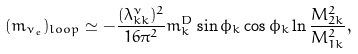Convert formula to latex. <formula><loc_0><loc_0><loc_500><loc_500>( m _ { \nu _ { e } } ) _ { l o o p } \simeq - \frac { ( \lambda ^ { \nu } _ { k k } ) ^ { 2 } } { 1 6 \pi ^ { 2 } } m _ { k } ^ { D } \sin \phi _ { k } \cos \phi _ { k } \ln \frac { M _ { 2 k } ^ { 2 } } { M _ { 1 k } ^ { 2 } } ,</formula> 